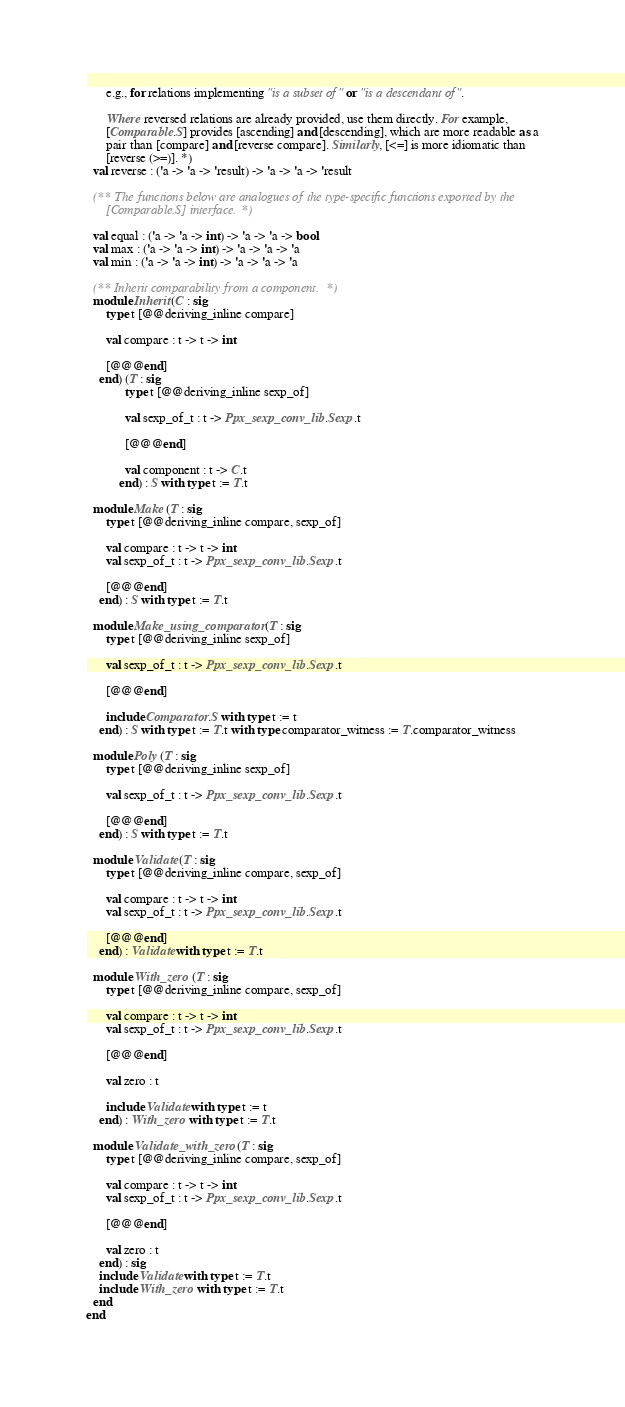<code> <loc_0><loc_0><loc_500><loc_500><_OCaml_>      e.g., for relations implementing "is a subset of" or "is a descendant of".

      Where reversed relations are already provided, use them directly. For example,
      [Comparable.S] provides [ascending] and [descending], which are more readable as a
      pair than [compare] and [reverse compare]. Similarly, [<=] is more idiomatic than
      [reverse (>=)]. *)
  val reverse : ('a -> 'a -> 'result) -> 'a -> 'a -> 'result

  (** The functions below are analogues of the type-specific functions exported by the
      [Comparable.S] interface. *)

  val equal : ('a -> 'a -> int) -> 'a -> 'a -> bool
  val max : ('a -> 'a -> int) -> 'a -> 'a -> 'a
  val min : ('a -> 'a -> int) -> 'a -> 'a -> 'a

  (** Inherit comparability from a component. *)
  module Inherit (C : sig
      type t [@@deriving_inline compare]

      val compare : t -> t -> int

      [@@@end]
    end) (T : sig
            type t [@@deriving_inline sexp_of]

            val sexp_of_t : t -> Ppx_sexp_conv_lib.Sexp.t

            [@@@end]

            val component : t -> C.t
          end) : S with type t := T.t

  module Make (T : sig
      type t [@@deriving_inline compare, sexp_of]

      val compare : t -> t -> int
      val sexp_of_t : t -> Ppx_sexp_conv_lib.Sexp.t

      [@@@end]
    end) : S with type t := T.t

  module Make_using_comparator (T : sig
      type t [@@deriving_inline sexp_of]

      val sexp_of_t : t -> Ppx_sexp_conv_lib.Sexp.t

      [@@@end]

      include Comparator.S with type t := t
    end) : S with type t := T.t with type comparator_witness := T.comparator_witness

  module Poly (T : sig
      type t [@@deriving_inline sexp_of]

      val sexp_of_t : t -> Ppx_sexp_conv_lib.Sexp.t

      [@@@end]
    end) : S with type t := T.t

  module Validate (T : sig
      type t [@@deriving_inline compare, sexp_of]

      val compare : t -> t -> int
      val sexp_of_t : t -> Ppx_sexp_conv_lib.Sexp.t

      [@@@end]
    end) : Validate with type t := T.t

  module With_zero (T : sig
      type t [@@deriving_inline compare, sexp_of]

      val compare : t -> t -> int
      val sexp_of_t : t -> Ppx_sexp_conv_lib.Sexp.t

      [@@@end]

      val zero : t

      include Validate with type t := t
    end) : With_zero with type t := T.t

  module Validate_with_zero (T : sig
      type t [@@deriving_inline compare, sexp_of]

      val compare : t -> t -> int
      val sexp_of_t : t -> Ppx_sexp_conv_lib.Sexp.t

      [@@@end]

      val zero : t
    end) : sig
    include Validate with type t := T.t
    include With_zero with type t := T.t
  end
end
</code> 